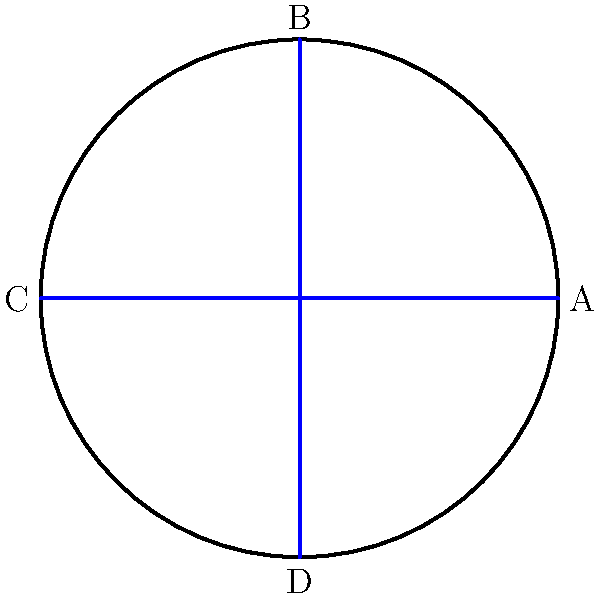A local American football team has designed a new logo consisting of a circle with four symmetrically placed lines, as shown in the figure. The logo has rotational symmetry. How many distinct rotations (including the identity rotation) will bring the logo back to its original position? To determine the number of distinct rotations that bring the logo back to its original position, we need to analyze its rotational symmetry:

1. The logo consists of a circle with four lines placed at 90-degree intervals.

2. We can rotate the logo by the following angles and it will look the same:
   a) 0° (identity rotation)
   b) 90° clockwise or counterclockwise
   c) 180°
   d) 270° clockwise (which is the same as 90° counterclockwise)

3. Any further rotation will repeat one of these positions.

4. Therefore, there are four distinct rotations (including the identity rotation) that bring the logo back to its original position.

In group theory terms, this logo has the rotational symmetry of the cyclic group $C_4$, which has order 4.
Answer: 4 